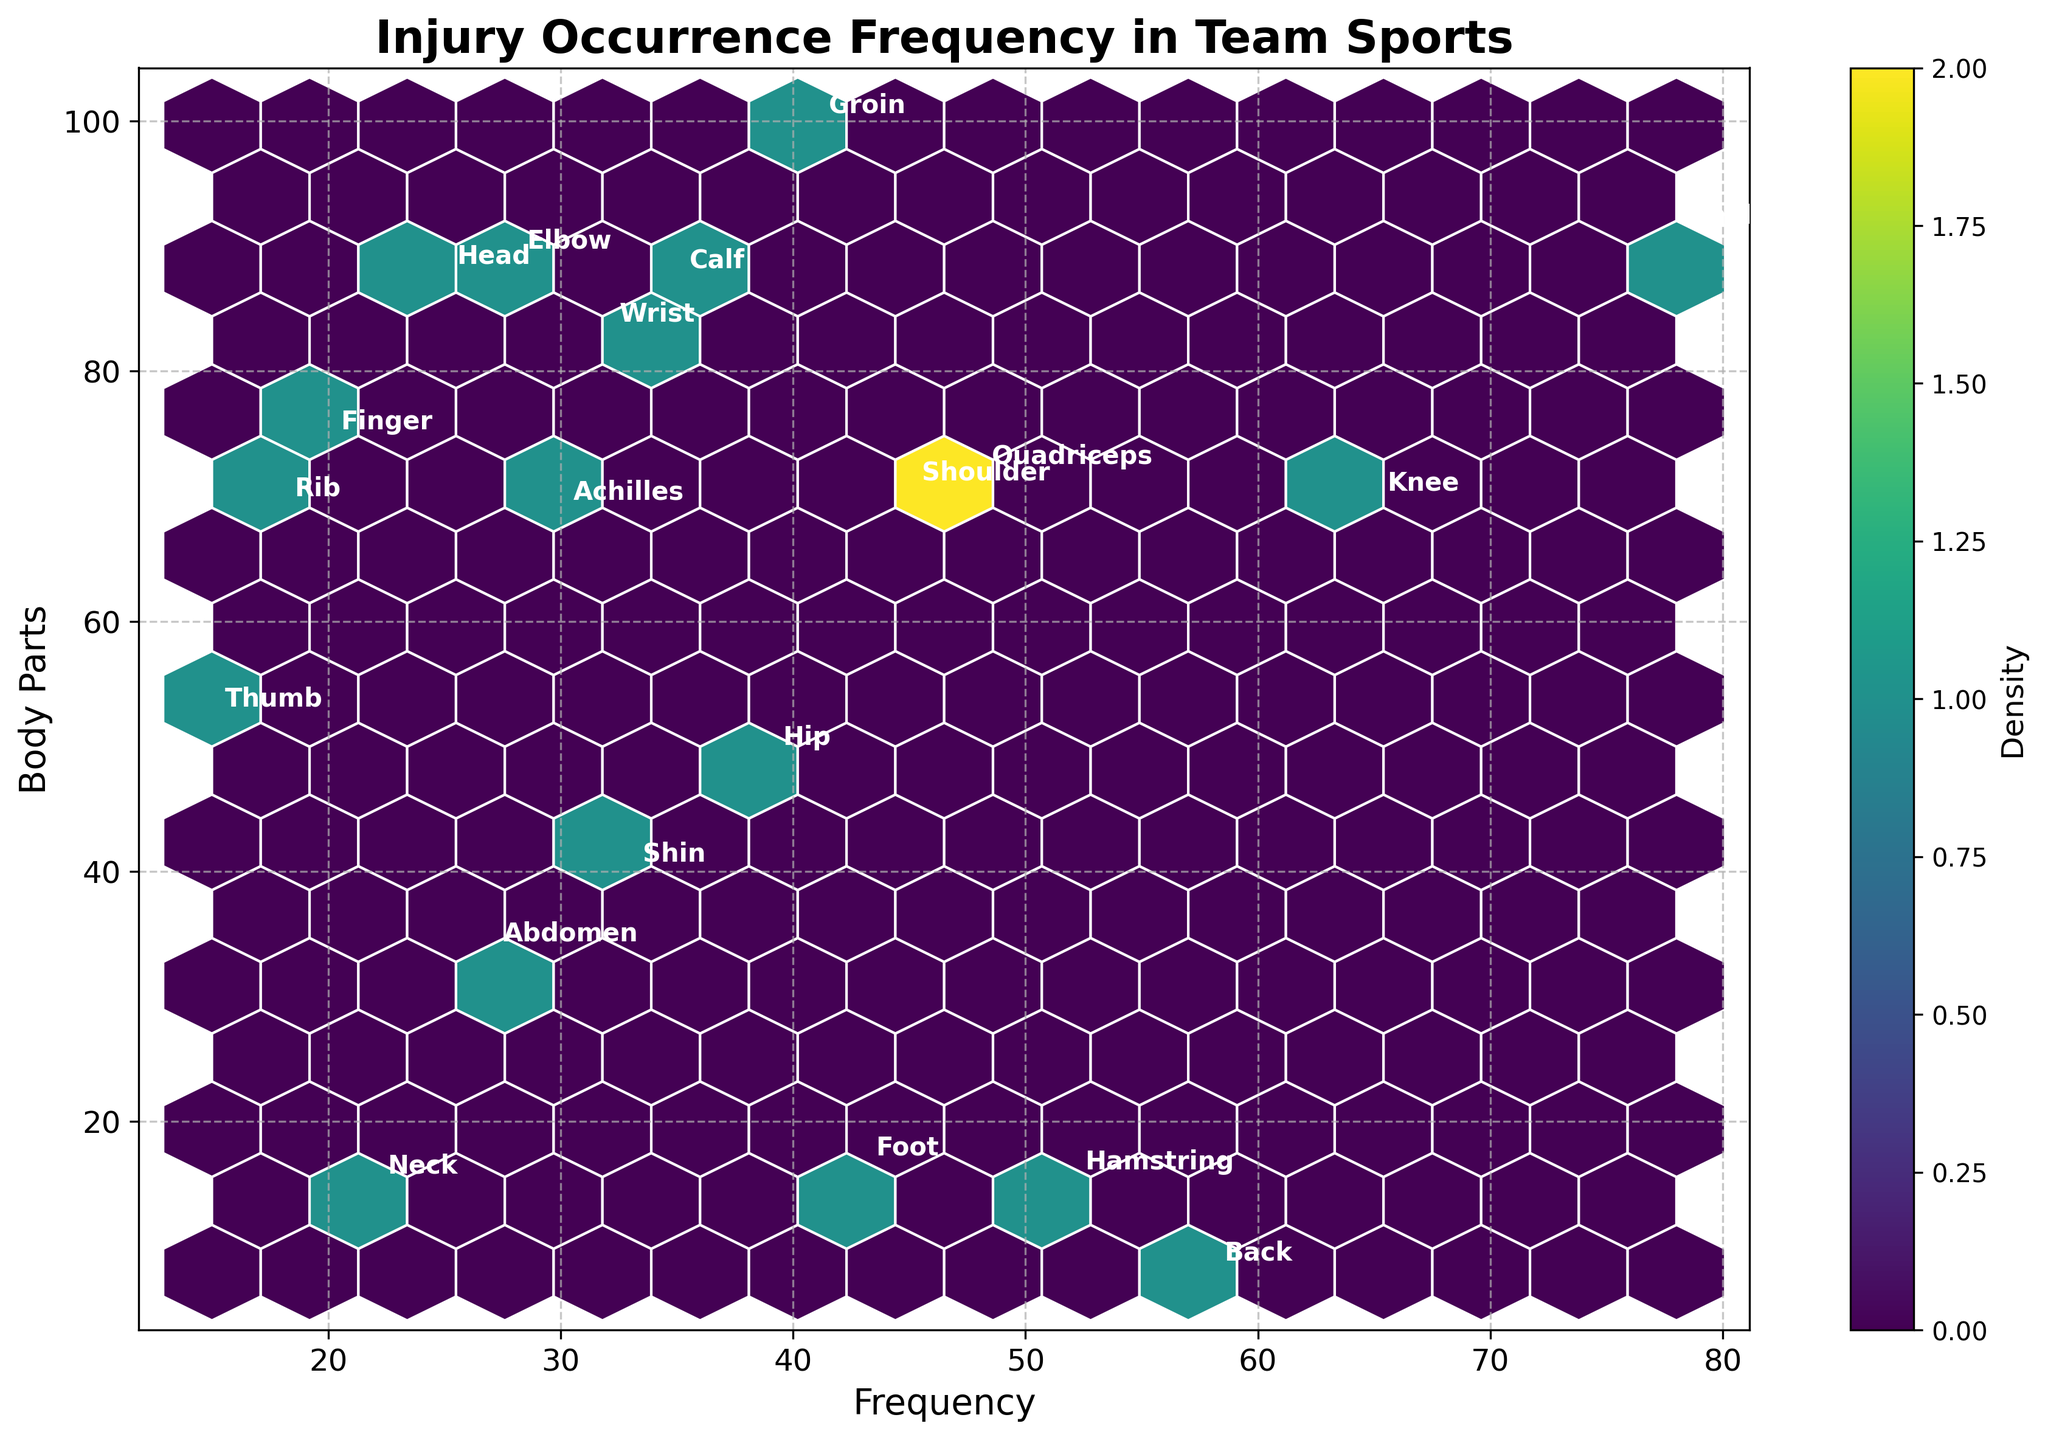What is the title of the plot? The title is located at the top center of the plot and is displayed prominently in a bold font.
Answer: Injury Occurrence Frequency in Team Sports What range of frequency values is displayed on the x-axis? The x-axis represents frequency values, and by observing the axis labels, one can determine the minimum and maximum values.
Answer: 15 to 80 Which body part has the highest injury frequency? By looking at the hexagons with higher density and identifying the annotations within those hexagons, one can determine the body part with the highest frequency.
Answer: Ankle How many body parts have a frequency higher than 50? By examining the hexagons and their annotations to identify which body parts have a frequency greater than 50.
Answer: 5 What is the average frequency of injuries for Soccer-related body parts visible in the plot? First, identify the body parts associated with Soccer (Ankle, Groin, Foot, Shin). Then sum their frequencies and divide by the number of body parts. Calculation: (78 + 41 + 43 + 33) / 4 = 48.75
Answer: 48.75 Compare the injury frequency between Tennis and Volleyball body parts. Which sport has a higher average injury frequency? Identify the body parts associated with each sport (Wrist, Abdomen for Tennis and Shoulder, Finger for Volleyball). Calculate the average frequency for each sport. Tennis: (32 + 27)/2 = 29.5, Volleyball: (45 + 20)/2 = 32.5. Volleyball has the higher average injury frequency.
Answer: Volleyball Which sports are represented by the lowest injury frequency values, and what are those values? Locate the hexagons with the lowest density and read the annotations to determine the sports and their corresponding frequencies.
Answer: Basketball (Thumb, 15), Ice Hockey (Rib, 18) What body part has the second-highest injury frequency in Basketball? Identify all body parts associated with Basketball and their frequencies, then determine which has the second-highest frequency.
Answer: Achilles Can you find which hexagon shows the highest density, and what is the associated body part? The highest density hexagon will have the most intense coloration. Note the annotation inside or near this hexagon to identify the body part.
Answer: Ankle Estimate the density value for the hexagons grouped around mid-range frequencies (30-50) on the x-axis. Look at the color and positioning of the hexagons within the 30-50 frequency range. Use the color bar to estimate the density value.
Answer: Approximately 5-10 